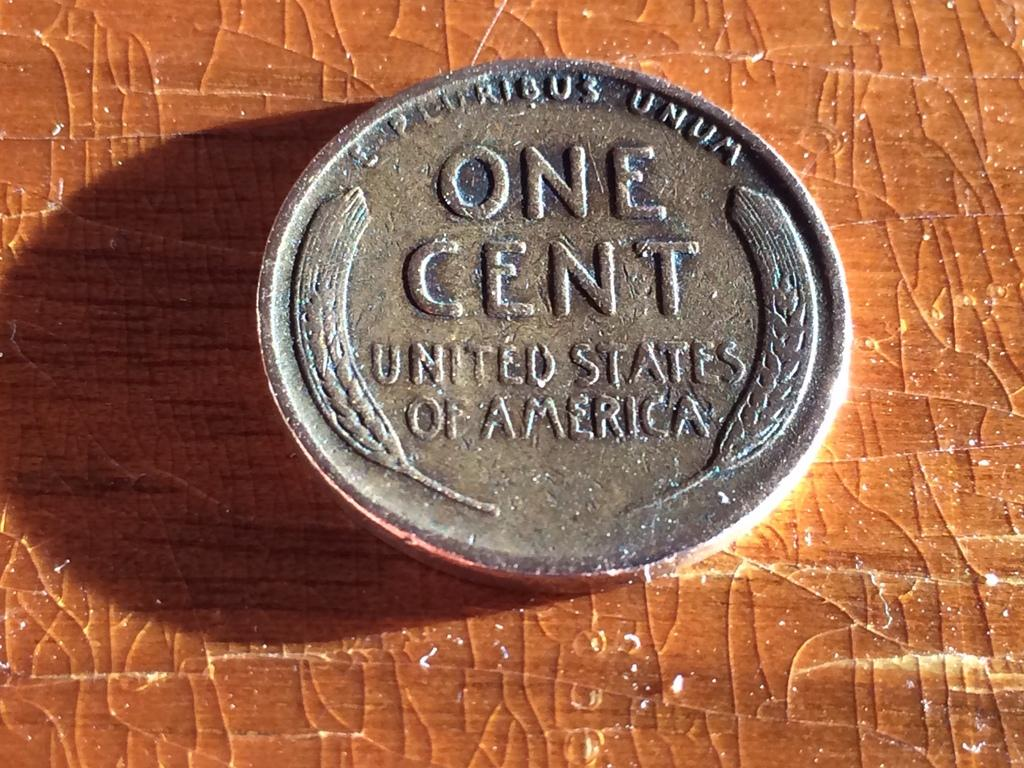<image>
Render a clear and concise summary of the photo. The old silver coin shown is currency from the United States of America. 